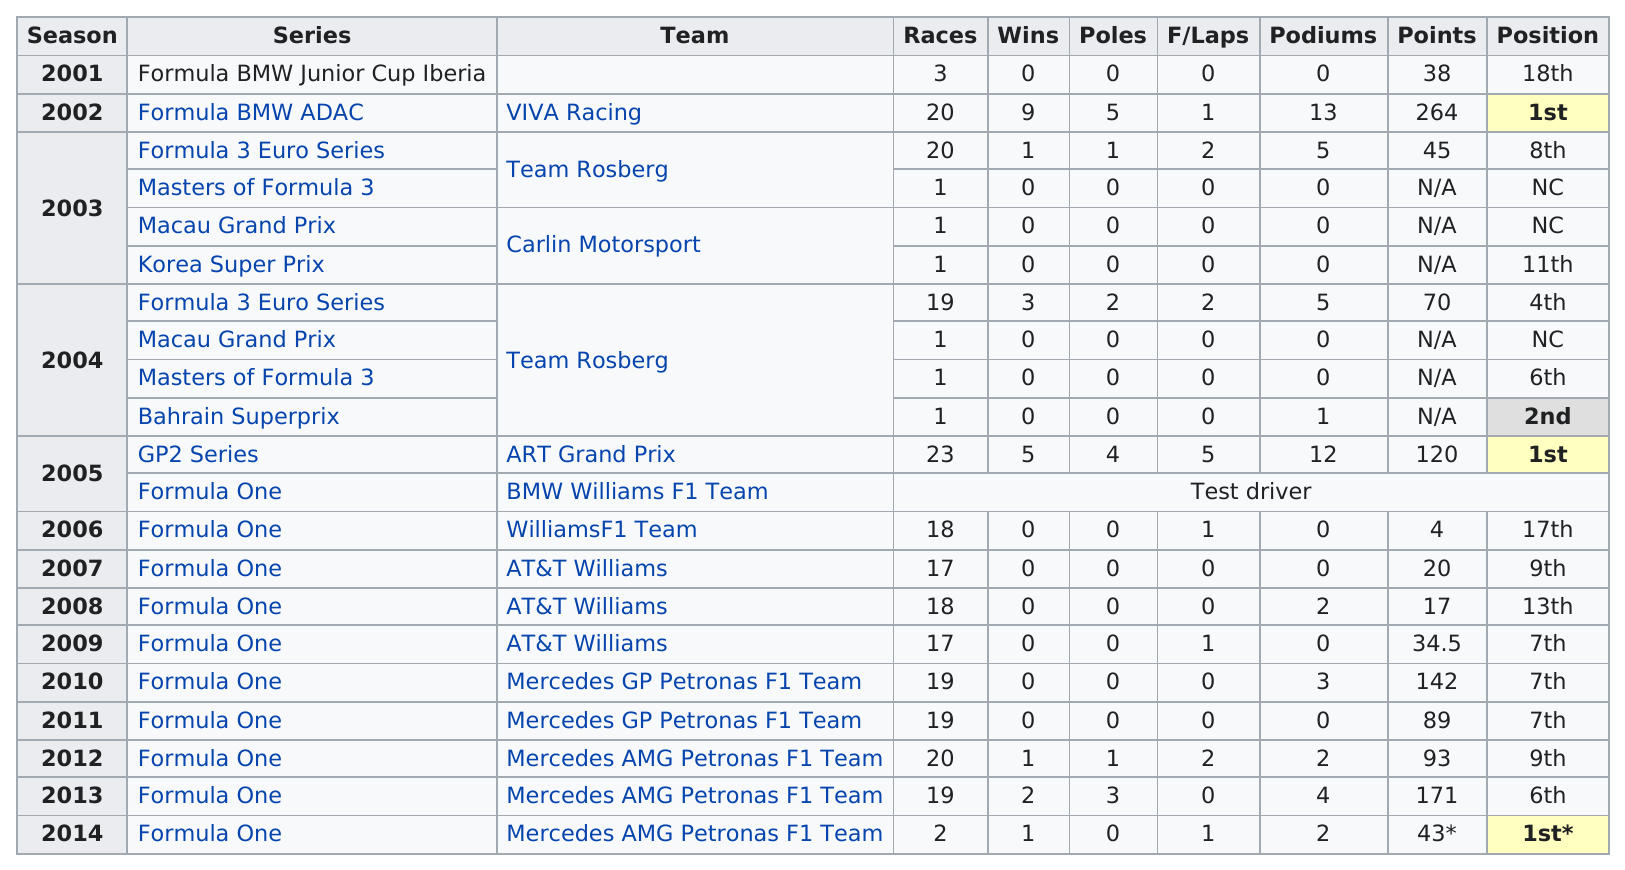Highlight a few significant elements in this photo. The first position was achieved three times. In his storied career, Nico Rosberg achieved a total of 22 wins, cementing his status as a racing legend. Nico Rosberg has been competing in the Formula One series for a total of 13 years. The person first raced in 2001. There have been three 1st place finishes. 